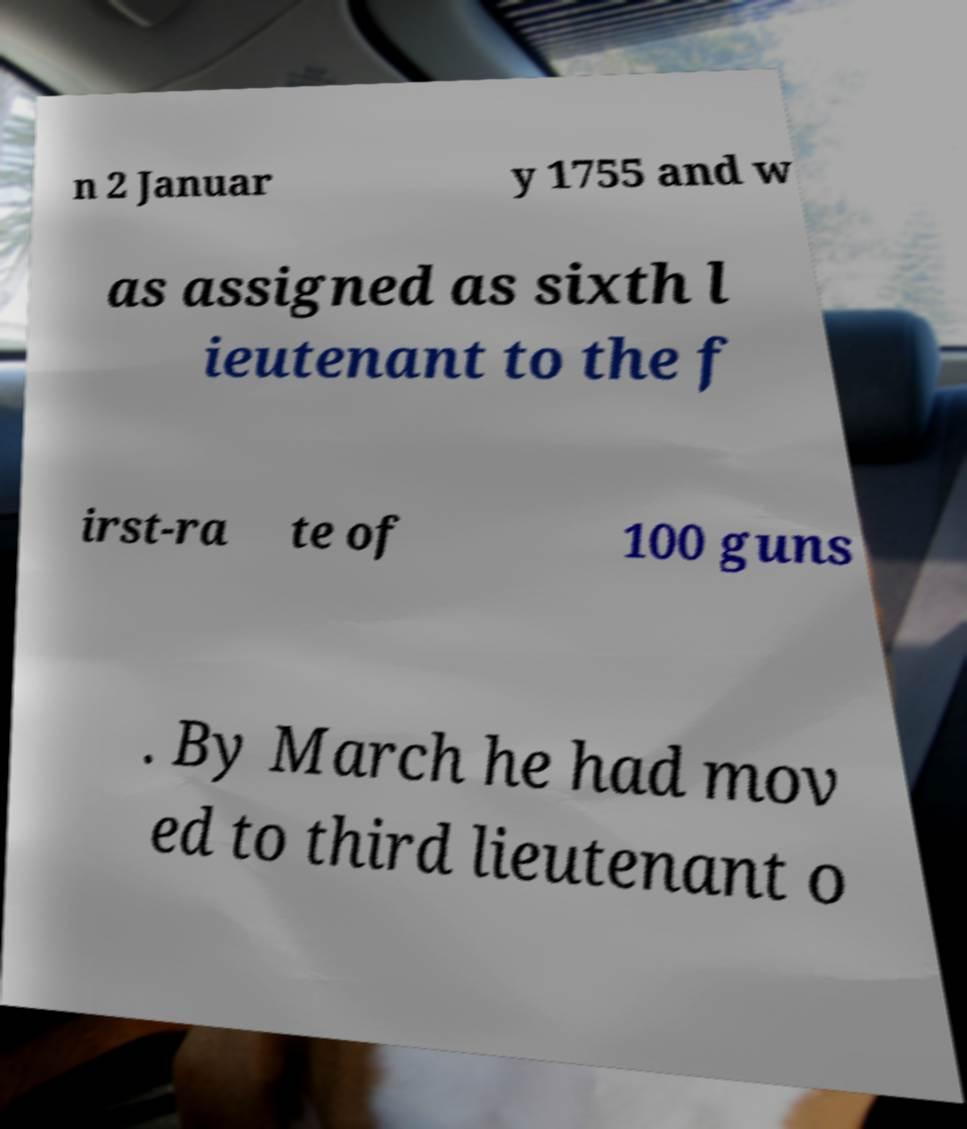There's text embedded in this image that I need extracted. Can you transcribe it verbatim? n 2 Januar y 1755 and w as assigned as sixth l ieutenant to the f irst-ra te of 100 guns . By March he had mov ed to third lieutenant o 